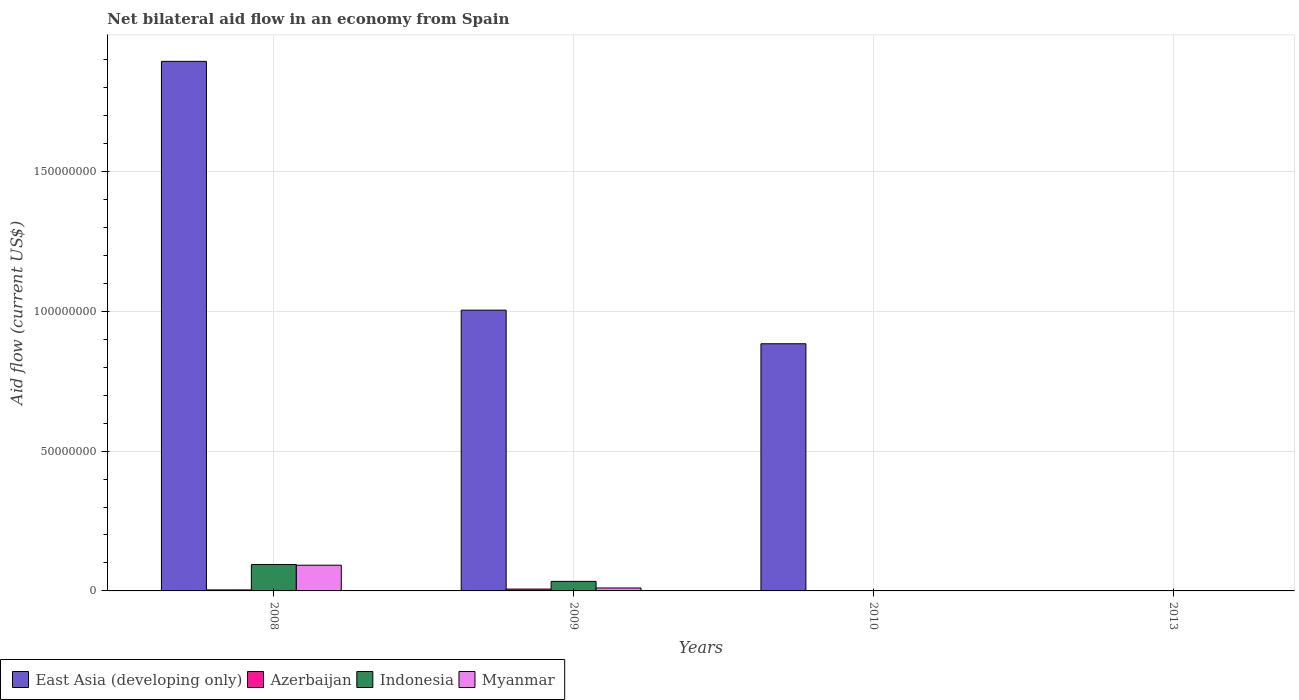Are the number of bars per tick equal to the number of legend labels?
Offer a very short reply. No. Are the number of bars on each tick of the X-axis equal?
Your response must be concise. No. What is the label of the 2nd group of bars from the left?
Keep it short and to the point. 2009. In how many cases, is the number of bars for a given year not equal to the number of legend labels?
Ensure brevity in your answer.  2. Across all years, what is the maximum net bilateral aid flow in Indonesia?
Provide a succinct answer. 9.45e+06. In which year was the net bilateral aid flow in Myanmar maximum?
Give a very brief answer. 2008. What is the total net bilateral aid flow in Azerbaijan in the graph?
Your answer should be very brief. 1.12e+06. What is the difference between the net bilateral aid flow in Azerbaijan in 2008 and that in 2010?
Offer a very short reply. 3.00e+05. What is the difference between the net bilateral aid flow in Indonesia in 2009 and the net bilateral aid flow in East Asia (developing only) in 2013?
Ensure brevity in your answer.  3.41e+06. What is the average net bilateral aid flow in East Asia (developing only) per year?
Provide a short and direct response. 9.45e+07. In the year 2009, what is the difference between the net bilateral aid flow in Myanmar and net bilateral aid flow in East Asia (developing only)?
Offer a terse response. -9.93e+07. What is the ratio of the net bilateral aid flow in Azerbaijan in 2008 to that in 2013?
Keep it short and to the point. 7.2. Is the difference between the net bilateral aid flow in Myanmar in 2008 and 2009 greater than the difference between the net bilateral aid flow in East Asia (developing only) in 2008 and 2009?
Give a very brief answer. No. What is the difference between the highest and the second highest net bilateral aid flow in East Asia (developing only)?
Offer a very short reply. 8.90e+07. What is the difference between the highest and the lowest net bilateral aid flow in Myanmar?
Provide a succinct answer. 9.18e+06. Is it the case that in every year, the sum of the net bilateral aid flow in Indonesia and net bilateral aid flow in East Asia (developing only) is greater than the net bilateral aid flow in Myanmar?
Provide a succinct answer. No. Are all the bars in the graph horizontal?
Provide a succinct answer. No. What is the difference between two consecutive major ticks on the Y-axis?
Your response must be concise. 5.00e+07. Does the graph contain any zero values?
Offer a very short reply. Yes. Does the graph contain grids?
Your answer should be compact. Yes. How many legend labels are there?
Your answer should be very brief. 4. What is the title of the graph?
Keep it short and to the point. Net bilateral aid flow in an economy from Spain. Does "Tuvalu" appear as one of the legend labels in the graph?
Your answer should be compact. No. What is the label or title of the X-axis?
Your answer should be very brief. Years. What is the label or title of the Y-axis?
Your answer should be very brief. Aid flow (current US$). What is the Aid flow (current US$) of East Asia (developing only) in 2008?
Provide a short and direct response. 1.89e+08. What is the Aid flow (current US$) in Azerbaijan in 2008?
Provide a short and direct response. 3.60e+05. What is the Aid flow (current US$) in Indonesia in 2008?
Make the answer very short. 9.45e+06. What is the Aid flow (current US$) of Myanmar in 2008?
Offer a very short reply. 9.19e+06. What is the Aid flow (current US$) of East Asia (developing only) in 2009?
Provide a succinct answer. 1.00e+08. What is the Aid flow (current US$) in Azerbaijan in 2009?
Keep it short and to the point. 6.50e+05. What is the Aid flow (current US$) in Indonesia in 2009?
Ensure brevity in your answer.  3.41e+06. What is the Aid flow (current US$) of Myanmar in 2009?
Your answer should be very brief. 1.05e+06. What is the Aid flow (current US$) in East Asia (developing only) in 2010?
Ensure brevity in your answer.  8.84e+07. What is the Aid flow (current US$) in Azerbaijan in 2010?
Your answer should be very brief. 6.00e+04. What is the Aid flow (current US$) in East Asia (developing only) in 2013?
Give a very brief answer. 0. Across all years, what is the maximum Aid flow (current US$) of East Asia (developing only)?
Make the answer very short. 1.89e+08. Across all years, what is the maximum Aid flow (current US$) of Azerbaijan?
Provide a short and direct response. 6.50e+05. Across all years, what is the maximum Aid flow (current US$) of Indonesia?
Your response must be concise. 9.45e+06. Across all years, what is the maximum Aid flow (current US$) of Myanmar?
Keep it short and to the point. 9.19e+06. What is the total Aid flow (current US$) of East Asia (developing only) in the graph?
Offer a very short reply. 3.78e+08. What is the total Aid flow (current US$) of Azerbaijan in the graph?
Your answer should be compact. 1.12e+06. What is the total Aid flow (current US$) of Indonesia in the graph?
Ensure brevity in your answer.  1.29e+07. What is the total Aid flow (current US$) in Myanmar in the graph?
Keep it short and to the point. 1.03e+07. What is the difference between the Aid flow (current US$) of East Asia (developing only) in 2008 and that in 2009?
Provide a short and direct response. 8.90e+07. What is the difference between the Aid flow (current US$) of Indonesia in 2008 and that in 2009?
Make the answer very short. 6.04e+06. What is the difference between the Aid flow (current US$) of Myanmar in 2008 and that in 2009?
Give a very brief answer. 8.14e+06. What is the difference between the Aid flow (current US$) in East Asia (developing only) in 2008 and that in 2010?
Offer a very short reply. 1.01e+08. What is the difference between the Aid flow (current US$) in Azerbaijan in 2008 and that in 2010?
Offer a very short reply. 3.00e+05. What is the difference between the Aid flow (current US$) in Myanmar in 2008 and that in 2010?
Offer a very short reply. 9.18e+06. What is the difference between the Aid flow (current US$) in Myanmar in 2008 and that in 2013?
Give a very brief answer. 9.18e+06. What is the difference between the Aid flow (current US$) of East Asia (developing only) in 2009 and that in 2010?
Keep it short and to the point. 1.20e+07. What is the difference between the Aid flow (current US$) in Azerbaijan in 2009 and that in 2010?
Your answer should be very brief. 5.90e+05. What is the difference between the Aid flow (current US$) of Myanmar in 2009 and that in 2010?
Offer a terse response. 1.04e+06. What is the difference between the Aid flow (current US$) in Myanmar in 2009 and that in 2013?
Your response must be concise. 1.04e+06. What is the difference between the Aid flow (current US$) of Azerbaijan in 2010 and that in 2013?
Ensure brevity in your answer.  10000. What is the difference between the Aid flow (current US$) of East Asia (developing only) in 2008 and the Aid flow (current US$) of Azerbaijan in 2009?
Your answer should be very brief. 1.89e+08. What is the difference between the Aid flow (current US$) of East Asia (developing only) in 2008 and the Aid flow (current US$) of Indonesia in 2009?
Make the answer very short. 1.86e+08. What is the difference between the Aid flow (current US$) in East Asia (developing only) in 2008 and the Aid flow (current US$) in Myanmar in 2009?
Keep it short and to the point. 1.88e+08. What is the difference between the Aid flow (current US$) of Azerbaijan in 2008 and the Aid flow (current US$) of Indonesia in 2009?
Give a very brief answer. -3.05e+06. What is the difference between the Aid flow (current US$) in Azerbaijan in 2008 and the Aid flow (current US$) in Myanmar in 2009?
Ensure brevity in your answer.  -6.90e+05. What is the difference between the Aid flow (current US$) in Indonesia in 2008 and the Aid flow (current US$) in Myanmar in 2009?
Offer a very short reply. 8.40e+06. What is the difference between the Aid flow (current US$) in East Asia (developing only) in 2008 and the Aid flow (current US$) in Azerbaijan in 2010?
Offer a terse response. 1.89e+08. What is the difference between the Aid flow (current US$) of East Asia (developing only) in 2008 and the Aid flow (current US$) of Myanmar in 2010?
Provide a succinct answer. 1.89e+08. What is the difference between the Aid flow (current US$) in Azerbaijan in 2008 and the Aid flow (current US$) in Myanmar in 2010?
Offer a very short reply. 3.50e+05. What is the difference between the Aid flow (current US$) in Indonesia in 2008 and the Aid flow (current US$) in Myanmar in 2010?
Offer a terse response. 9.44e+06. What is the difference between the Aid flow (current US$) of East Asia (developing only) in 2008 and the Aid flow (current US$) of Azerbaijan in 2013?
Your response must be concise. 1.89e+08. What is the difference between the Aid flow (current US$) of East Asia (developing only) in 2008 and the Aid flow (current US$) of Myanmar in 2013?
Your answer should be compact. 1.89e+08. What is the difference between the Aid flow (current US$) in Azerbaijan in 2008 and the Aid flow (current US$) in Myanmar in 2013?
Provide a succinct answer. 3.50e+05. What is the difference between the Aid flow (current US$) in Indonesia in 2008 and the Aid flow (current US$) in Myanmar in 2013?
Give a very brief answer. 9.44e+06. What is the difference between the Aid flow (current US$) in East Asia (developing only) in 2009 and the Aid flow (current US$) in Azerbaijan in 2010?
Provide a succinct answer. 1.00e+08. What is the difference between the Aid flow (current US$) of East Asia (developing only) in 2009 and the Aid flow (current US$) of Myanmar in 2010?
Offer a terse response. 1.00e+08. What is the difference between the Aid flow (current US$) in Azerbaijan in 2009 and the Aid flow (current US$) in Myanmar in 2010?
Ensure brevity in your answer.  6.40e+05. What is the difference between the Aid flow (current US$) of Indonesia in 2009 and the Aid flow (current US$) of Myanmar in 2010?
Ensure brevity in your answer.  3.40e+06. What is the difference between the Aid flow (current US$) of East Asia (developing only) in 2009 and the Aid flow (current US$) of Azerbaijan in 2013?
Offer a terse response. 1.00e+08. What is the difference between the Aid flow (current US$) of East Asia (developing only) in 2009 and the Aid flow (current US$) of Myanmar in 2013?
Offer a very short reply. 1.00e+08. What is the difference between the Aid flow (current US$) in Azerbaijan in 2009 and the Aid flow (current US$) in Myanmar in 2013?
Provide a succinct answer. 6.40e+05. What is the difference between the Aid flow (current US$) of Indonesia in 2009 and the Aid flow (current US$) of Myanmar in 2013?
Keep it short and to the point. 3.40e+06. What is the difference between the Aid flow (current US$) of East Asia (developing only) in 2010 and the Aid flow (current US$) of Azerbaijan in 2013?
Your answer should be very brief. 8.83e+07. What is the difference between the Aid flow (current US$) of East Asia (developing only) in 2010 and the Aid flow (current US$) of Myanmar in 2013?
Make the answer very short. 8.84e+07. What is the difference between the Aid flow (current US$) in Azerbaijan in 2010 and the Aid flow (current US$) in Myanmar in 2013?
Keep it short and to the point. 5.00e+04. What is the average Aid flow (current US$) in East Asia (developing only) per year?
Your response must be concise. 9.45e+07. What is the average Aid flow (current US$) of Azerbaijan per year?
Give a very brief answer. 2.80e+05. What is the average Aid flow (current US$) of Indonesia per year?
Ensure brevity in your answer.  3.22e+06. What is the average Aid flow (current US$) of Myanmar per year?
Provide a succinct answer. 2.56e+06. In the year 2008, what is the difference between the Aid flow (current US$) in East Asia (developing only) and Aid flow (current US$) in Azerbaijan?
Provide a short and direct response. 1.89e+08. In the year 2008, what is the difference between the Aid flow (current US$) in East Asia (developing only) and Aid flow (current US$) in Indonesia?
Keep it short and to the point. 1.80e+08. In the year 2008, what is the difference between the Aid flow (current US$) in East Asia (developing only) and Aid flow (current US$) in Myanmar?
Make the answer very short. 1.80e+08. In the year 2008, what is the difference between the Aid flow (current US$) in Azerbaijan and Aid flow (current US$) in Indonesia?
Give a very brief answer. -9.09e+06. In the year 2008, what is the difference between the Aid flow (current US$) of Azerbaijan and Aid flow (current US$) of Myanmar?
Give a very brief answer. -8.83e+06. In the year 2008, what is the difference between the Aid flow (current US$) of Indonesia and Aid flow (current US$) of Myanmar?
Provide a short and direct response. 2.60e+05. In the year 2009, what is the difference between the Aid flow (current US$) of East Asia (developing only) and Aid flow (current US$) of Azerbaijan?
Your response must be concise. 9.97e+07. In the year 2009, what is the difference between the Aid flow (current US$) of East Asia (developing only) and Aid flow (current US$) of Indonesia?
Ensure brevity in your answer.  9.70e+07. In the year 2009, what is the difference between the Aid flow (current US$) in East Asia (developing only) and Aid flow (current US$) in Myanmar?
Provide a short and direct response. 9.93e+07. In the year 2009, what is the difference between the Aid flow (current US$) in Azerbaijan and Aid flow (current US$) in Indonesia?
Keep it short and to the point. -2.76e+06. In the year 2009, what is the difference between the Aid flow (current US$) in Azerbaijan and Aid flow (current US$) in Myanmar?
Your response must be concise. -4.00e+05. In the year 2009, what is the difference between the Aid flow (current US$) of Indonesia and Aid flow (current US$) of Myanmar?
Your response must be concise. 2.36e+06. In the year 2010, what is the difference between the Aid flow (current US$) in East Asia (developing only) and Aid flow (current US$) in Azerbaijan?
Offer a very short reply. 8.83e+07. In the year 2010, what is the difference between the Aid flow (current US$) of East Asia (developing only) and Aid flow (current US$) of Myanmar?
Make the answer very short. 8.84e+07. What is the ratio of the Aid flow (current US$) of East Asia (developing only) in 2008 to that in 2009?
Provide a succinct answer. 1.89. What is the ratio of the Aid flow (current US$) in Azerbaijan in 2008 to that in 2009?
Ensure brevity in your answer.  0.55. What is the ratio of the Aid flow (current US$) in Indonesia in 2008 to that in 2009?
Give a very brief answer. 2.77. What is the ratio of the Aid flow (current US$) in Myanmar in 2008 to that in 2009?
Offer a very short reply. 8.75. What is the ratio of the Aid flow (current US$) in East Asia (developing only) in 2008 to that in 2010?
Provide a short and direct response. 2.14. What is the ratio of the Aid flow (current US$) in Azerbaijan in 2008 to that in 2010?
Ensure brevity in your answer.  6. What is the ratio of the Aid flow (current US$) in Myanmar in 2008 to that in 2010?
Ensure brevity in your answer.  919. What is the ratio of the Aid flow (current US$) in Myanmar in 2008 to that in 2013?
Ensure brevity in your answer.  919. What is the ratio of the Aid flow (current US$) of East Asia (developing only) in 2009 to that in 2010?
Keep it short and to the point. 1.14. What is the ratio of the Aid flow (current US$) of Azerbaijan in 2009 to that in 2010?
Make the answer very short. 10.83. What is the ratio of the Aid flow (current US$) in Myanmar in 2009 to that in 2010?
Keep it short and to the point. 105. What is the ratio of the Aid flow (current US$) in Myanmar in 2009 to that in 2013?
Your response must be concise. 105. What is the ratio of the Aid flow (current US$) in Azerbaijan in 2010 to that in 2013?
Ensure brevity in your answer.  1.2. What is the ratio of the Aid flow (current US$) of Myanmar in 2010 to that in 2013?
Give a very brief answer. 1. What is the difference between the highest and the second highest Aid flow (current US$) in East Asia (developing only)?
Provide a succinct answer. 8.90e+07. What is the difference between the highest and the second highest Aid flow (current US$) of Myanmar?
Provide a short and direct response. 8.14e+06. What is the difference between the highest and the lowest Aid flow (current US$) of East Asia (developing only)?
Give a very brief answer. 1.89e+08. What is the difference between the highest and the lowest Aid flow (current US$) of Indonesia?
Offer a very short reply. 9.45e+06. What is the difference between the highest and the lowest Aid flow (current US$) of Myanmar?
Your answer should be compact. 9.18e+06. 